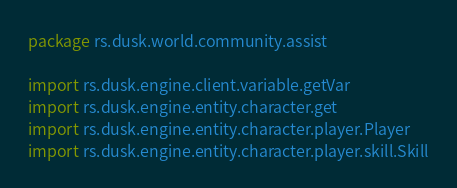<code> <loc_0><loc_0><loc_500><loc_500><_Kotlin_>package rs.dusk.world.community.assist

import rs.dusk.engine.client.variable.getVar
import rs.dusk.engine.entity.character.get
import rs.dusk.engine.entity.character.player.Player
import rs.dusk.engine.entity.character.player.skill.Skill</code> 